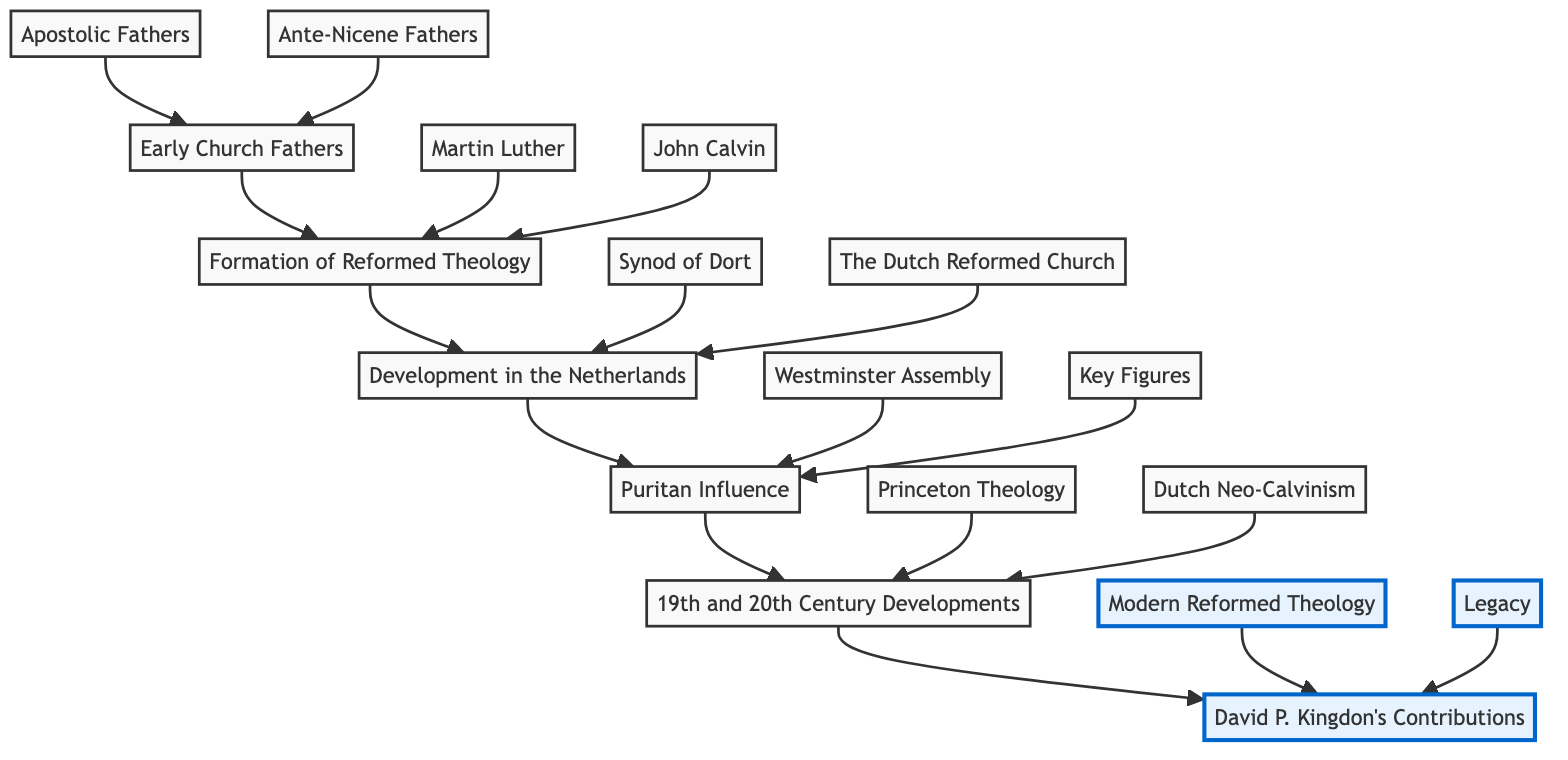What are the two categories under Early Church Fathers? The Early Church Fathers category contains two sub-elements: Apostolic Fathers and Ante-Nicene Fathers.
Answer: Apostolic Fathers, Ante-Nicene Fathers Who is associated with the Synod of Dort? The sub-component Synod of Dort falls under the Development in the Netherlands category. It specifically addresses countering Arminianism.
Answer: Synod of Dort How many main sections are in the flow chart? The flow chart consists of five main sections from Early Church Fathers to David P. Kingdon's Contributions. Each section flows sequentially.
Answer: Five Which theologian is linked directly to the formation of Reformed Theology? Martin Luther is directly linked to the formation of Reformed Theology. He is one of the key figures listed under this section.
Answer: Martin Luther What is the significance of David P. Kingdon's contributions? David P. Kingdon's contributions are significant for his key publications and theological impact, which are depicted at the top of the chart.
Answer: Key Publications and Theological Impact What transitions from Puritan Influence to 19th and 20th Century Developments? The transition from Puritan Influence to 19th and 20th Century Developments is marked by the historical development of Princeton Theology and Dutch Neo-Calvinism.
Answer: Princeton Theology, Dutch Neo-Calvinism What are the two main contributions of David P. Kingdon? David P. Kingdon's contributions are divided into Modern Reformed Theology and Legacy, highlighting his impact on contemporary thought.
Answer: Modern Reformed Theology, Legacy Which figure is associated with the Westminster Assembly? The Westminster Assembly is associated with the Puritan Influence section, where it contributes significantly to the development of the Westminster Confession of Faith.
Answer: Westminster Assembly How do the Ante-Nicene Fathers relate to Early Church Fathers? The Ante-Nicene Fathers are sub-elements within the Early Church Fathers category, showcasing their historical importance.
Answer: Ante-Nicene Fathers 